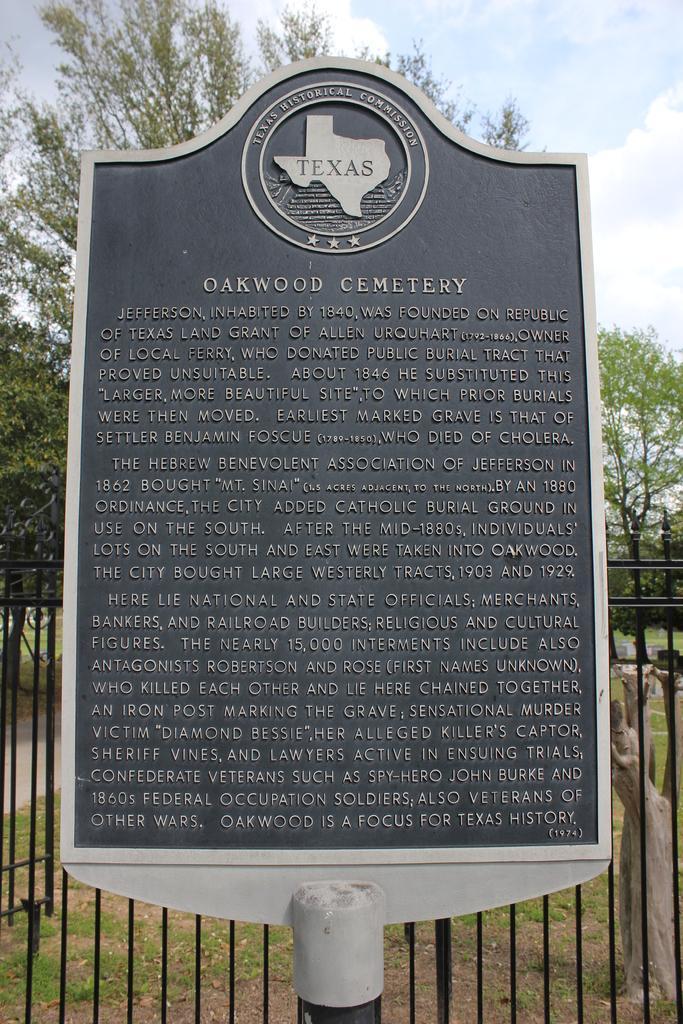Could you give a brief overview of what you see in this image? In this picture, there is a board in the center. On the board, there is some text and pictures engraved on it. Behind it, there is a fence. In the background, there are trees and sky. 